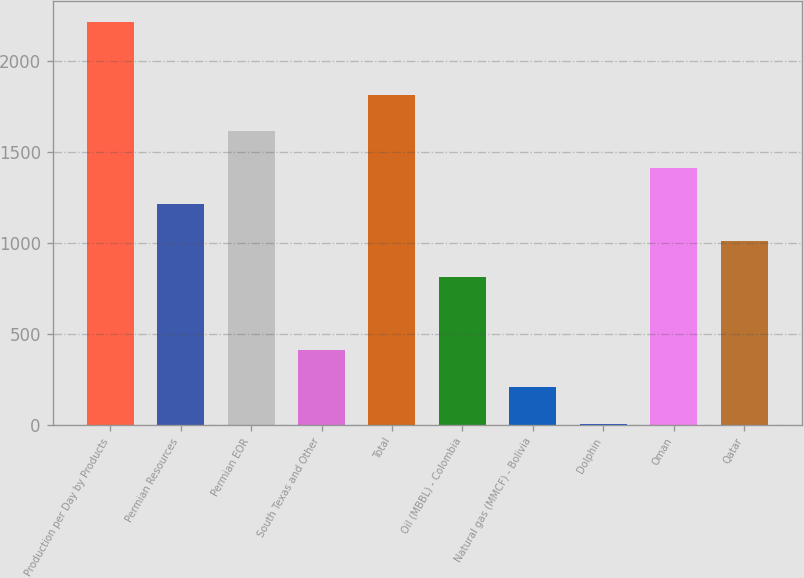Convert chart to OTSL. <chart><loc_0><loc_0><loc_500><loc_500><bar_chart><fcel>Production per Day by Products<fcel>Permian Resources<fcel>Permian EOR<fcel>South Texas and Other<fcel>Total<fcel>Oil (MBBL) - Colombia<fcel>Natural gas (MMCF) - Bolivia<fcel>Dolphin<fcel>Oman<fcel>Qatar<nl><fcel>2215.8<fcel>1211.8<fcel>1613.4<fcel>408.6<fcel>1814.2<fcel>810.2<fcel>207.8<fcel>7<fcel>1412.6<fcel>1011<nl></chart> 